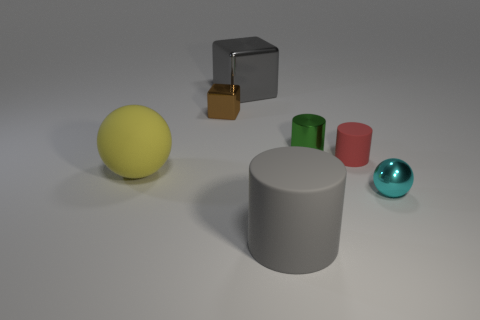What number of large red shiny blocks are there?
Provide a short and direct response. 0. What number of big rubber objects are left of the large block and on the right side of the yellow matte ball?
Make the answer very short. 0. What is the large yellow thing made of?
Your response must be concise. Rubber. Are any large red spheres visible?
Make the answer very short. No. There is a object that is in front of the metal sphere; what is its color?
Offer a terse response. Gray. How many cylinders are in front of the yellow object that is behind the ball to the right of the large yellow object?
Give a very brief answer. 1. What is the object that is both on the left side of the green metallic thing and to the right of the gray shiny object made of?
Give a very brief answer. Rubber. Is the cyan ball made of the same material as the tiny cylinder that is left of the small rubber object?
Your answer should be very brief. Yes. Is the number of tiny green shiny things that are left of the tiny green metallic cylinder greater than the number of small cyan shiny things that are left of the gray cylinder?
Offer a terse response. No. What is the shape of the brown shiny object?
Your response must be concise. Cube. 